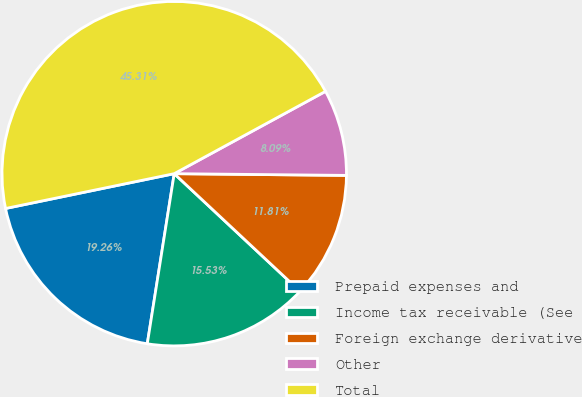<chart> <loc_0><loc_0><loc_500><loc_500><pie_chart><fcel>Prepaid expenses and<fcel>Income tax receivable (See<fcel>Foreign exchange derivative<fcel>Other<fcel>Total<nl><fcel>19.26%<fcel>15.53%<fcel>11.81%<fcel>8.09%<fcel>45.31%<nl></chart> 